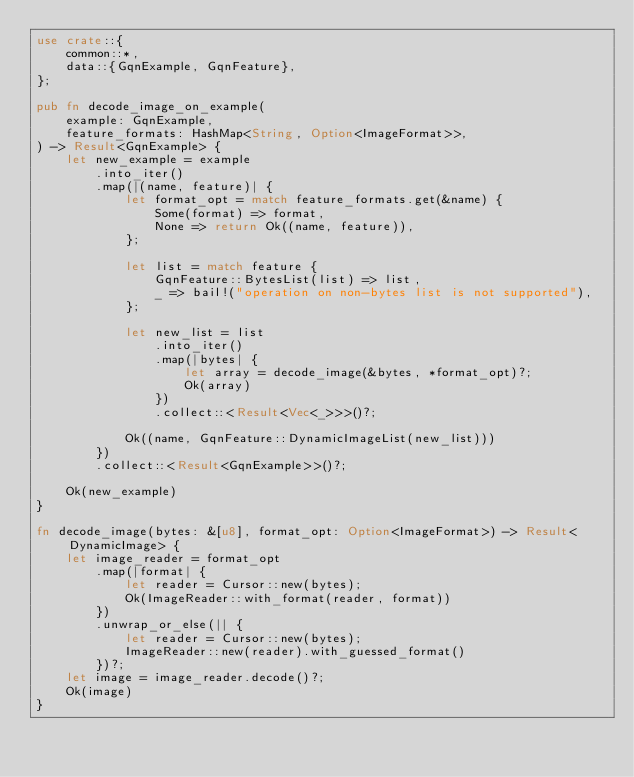Convert code to text. <code><loc_0><loc_0><loc_500><loc_500><_Rust_>use crate::{
    common::*,
    data::{GqnExample, GqnFeature},
};

pub fn decode_image_on_example(
    example: GqnExample,
    feature_formats: HashMap<String, Option<ImageFormat>>,
) -> Result<GqnExample> {
    let new_example = example
        .into_iter()
        .map(|(name, feature)| {
            let format_opt = match feature_formats.get(&name) {
                Some(format) => format,
                None => return Ok((name, feature)),
            };

            let list = match feature {
                GqnFeature::BytesList(list) => list,
                _ => bail!("operation on non-bytes list is not supported"),
            };

            let new_list = list
                .into_iter()
                .map(|bytes| {
                    let array = decode_image(&bytes, *format_opt)?;
                    Ok(array)
                })
                .collect::<Result<Vec<_>>>()?;

            Ok((name, GqnFeature::DynamicImageList(new_list)))
        })
        .collect::<Result<GqnExample>>()?;

    Ok(new_example)
}

fn decode_image(bytes: &[u8], format_opt: Option<ImageFormat>) -> Result<DynamicImage> {
    let image_reader = format_opt
        .map(|format| {
            let reader = Cursor::new(bytes);
            Ok(ImageReader::with_format(reader, format))
        })
        .unwrap_or_else(|| {
            let reader = Cursor::new(bytes);
            ImageReader::new(reader).with_guessed_format()
        })?;
    let image = image_reader.decode()?;
    Ok(image)
}
</code> 